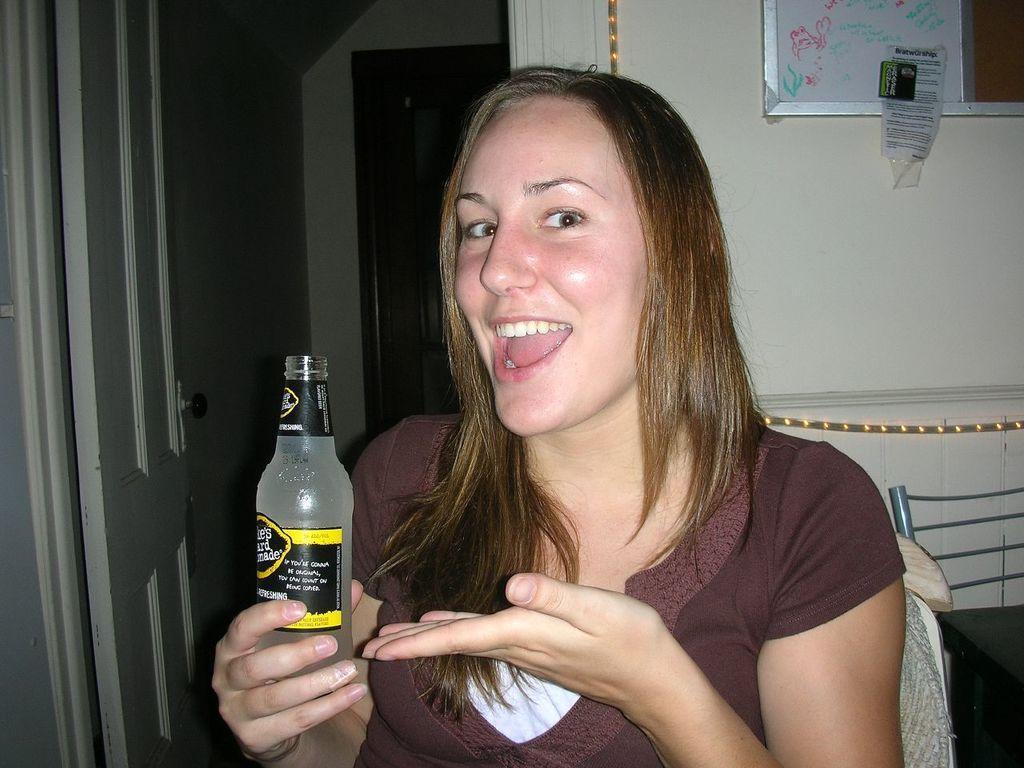How would you summarize this image in a sentence or two? This picture is taken inside a room. In the middle there is a lady wearing brown t shirt is holding a bottle. She is smiling. Beside her there is a table and chair. On the left side there is a door. On the background there is a wall. On the wall there is a board. 